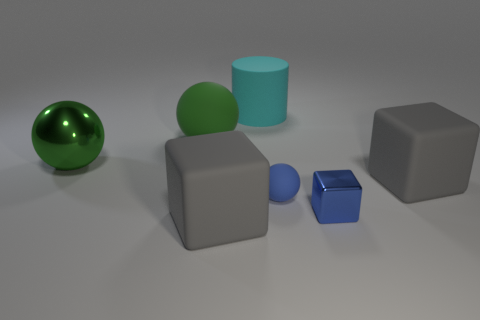There is a thing that is the same color as the large metallic sphere; what is its size?
Your response must be concise. Large. There is a blue metal thing; are there any matte things in front of it?
Offer a terse response. Yes. There is a big cylinder that is to the left of the small blue object that is on the left side of the tiny object in front of the blue rubber sphere; what color is it?
Provide a succinct answer. Cyan. What number of things are in front of the tiny blue block and to the right of the small blue rubber ball?
Provide a succinct answer. 0. How many cubes are blue matte objects or small shiny things?
Provide a short and direct response. 1. Is there a small blue thing?
Provide a succinct answer. Yes. What number of other objects are there of the same material as the large cylinder?
Provide a short and direct response. 4. What is the material of the sphere that is the same size as the metal block?
Give a very brief answer. Rubber. Does the gray matte object that is right of the tiny blue ball have the same shape as the small metallic thing?
Make the answer very short. Yes. Is the color of the large rubber ball the same as the metallic ball?
Ensure brevity in your answer.  Yes. 